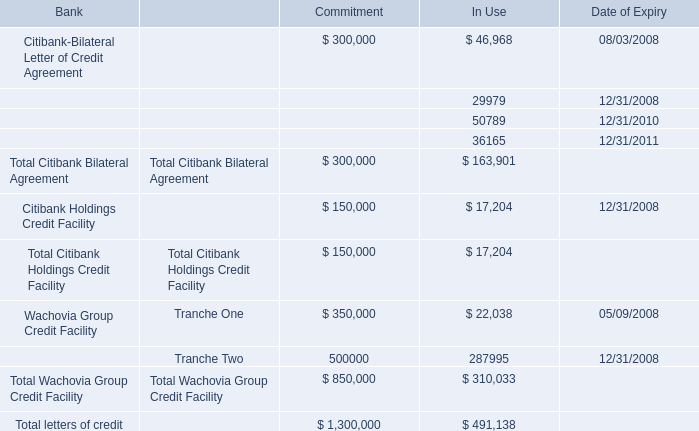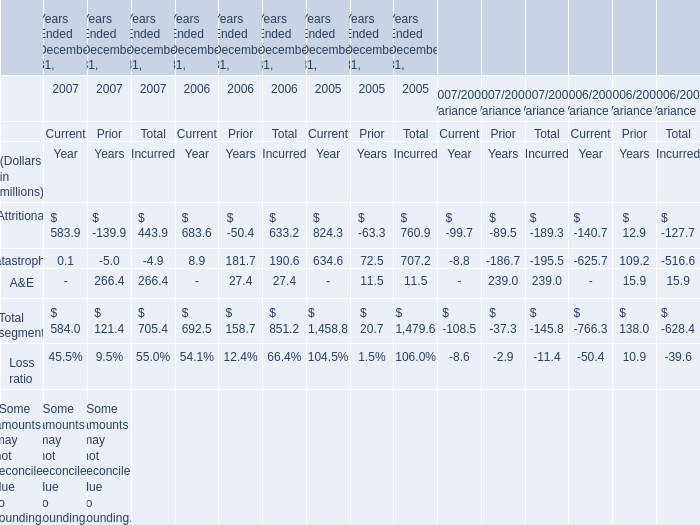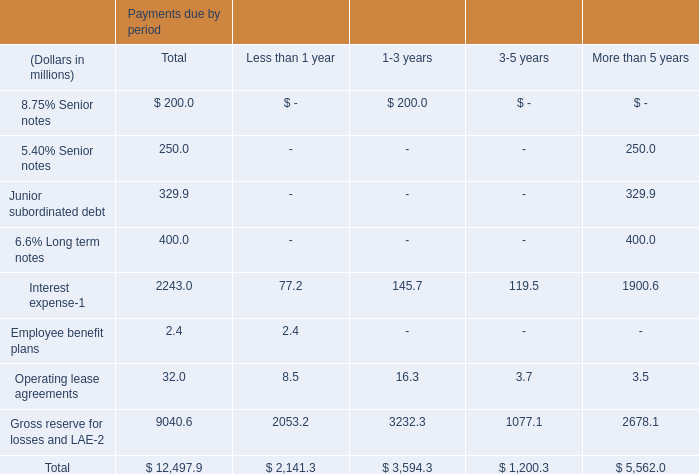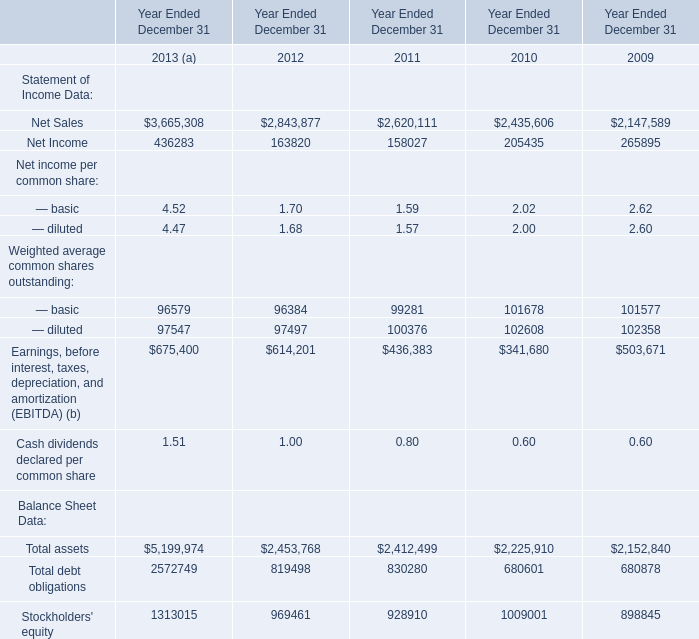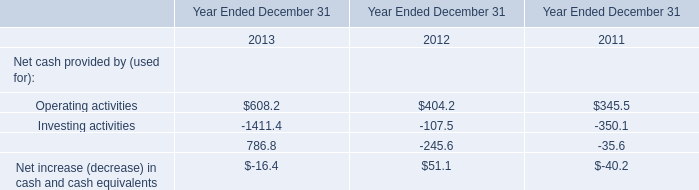What's the growth rate of the value of the amount for Total segment for Current Year in 2006 Ended December 31? 
Computations: ((692.5 - 1458.8) / 1458.8)
Answer: -0.52529. 